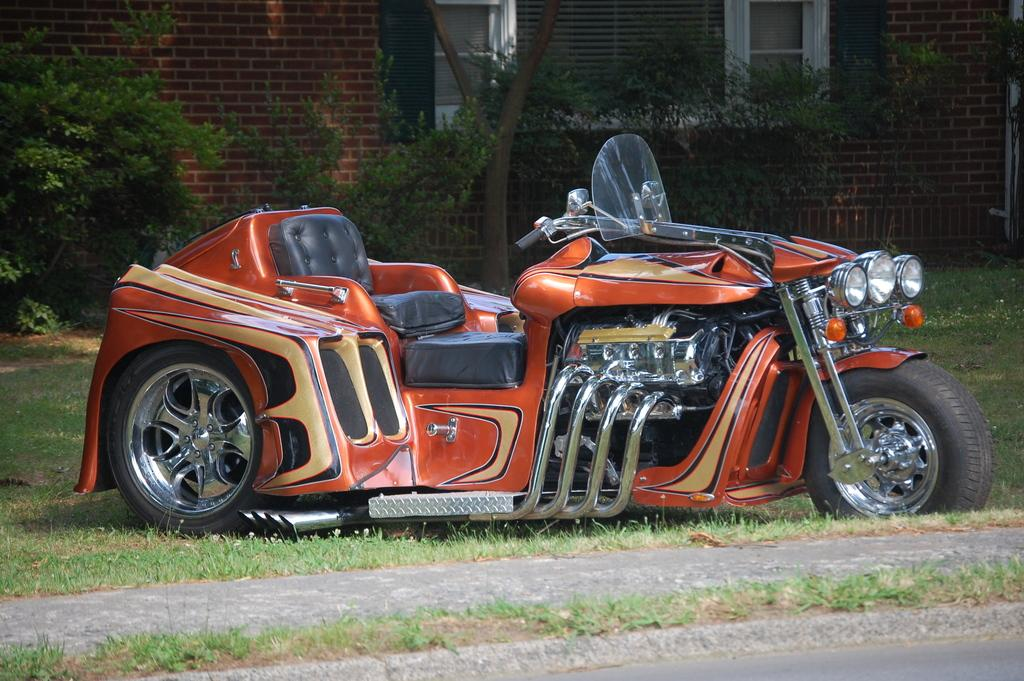What is parked in the image? There is a vehicle parked in the image. What can be seen behind the parked vehicle? There are trees behind the vehicle. What is located behind the trees in the image? There is a building behind the trees. What type of connection can be seen between the vehicle and the building in the image? There is no visible connection between the vehicle and the building in the image. 